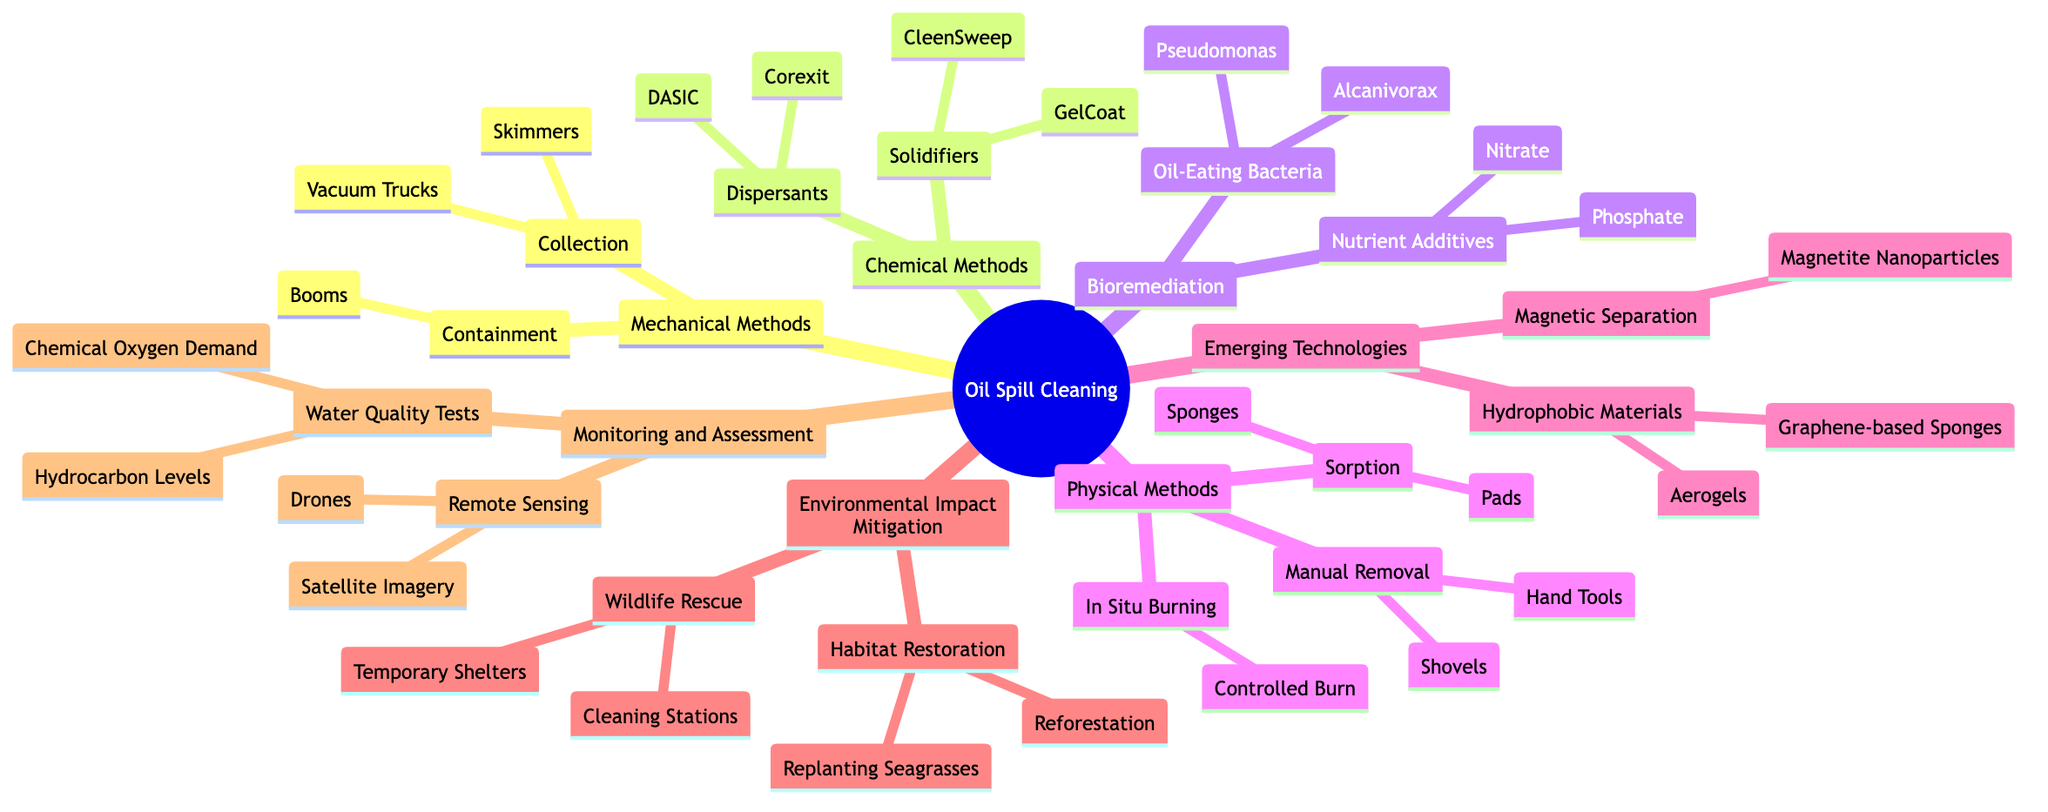What are two types of mechanical methods? The diagram presents "Mechanical Methods" which has two categories: "Containment" and "Collection." These categories represent the ways in which mechanical methods can be classified.
Answer: Containment, Collection How many chemical methods are listed? The "Chemical Methods" section includes two categories: "Dispersants" and "Solidifiers." Each of these categories contains two items, but the question only concerns the number of methods.
Answer: 2 Name a dispersant used in oil spill clean-up. Under the "Chemical Methods" section, specifically in the "Dispersants" category, two examples are provided: "Corexit" and "DASIC." Any of these examples would fulfill the requirement.
Answer: Corexit What is the first item under bioremediation? The "Bioremediation" section lists "Oil-Eating Bacteria" first, which has two specific examples under it. Thus, the answer refers to the first item mentioned in this category.
Answer: Oil-Eating Bacteria How do nutrient additives relate to bioremediation? The "Bioremediation" section includes two subcategories: "Oil-Eating Bacteria" and "Nutrient Additives." Nutrient Additives directly support the bioremediation process by enhancing the effectiveness of the oil-eating bacteria. Therefore, they are connected as supportive elements in cleaning oil spills.
Answer: They support oil-eating bacteria How many items are listed under physical methods? The "Physical Methods" branch has three main categories: "Sorption," "In Situ Burning," and "Manual Removal." Each category contains at least one listed item. To determine the total number of items, we add them up: "Sorption" has two items, "In Situ Burning" has one item, and "Manual Removal" has two items.
Answer: 5 Which emerging technology uses magnetic separation? Under the "Emerging Technologies" section, the category of "Magnetic Separation" specifically includes "Magnetite Nanoparticles." This identifies it as a technology that utilizes magnetic properties to assist in cleaning oil spills.
Answer: Magnetite Nanoparticles What are the two parts of environmental impact mitigation? The "Environmental Impact Mitigation" section consists of two primary categories: "Wildlife Rescue" and "Habitat Restoration." Each category represents a focus area within the broader theme of mitigating effects from oil spills.
Answer: Wildlife Rescue, Habitat Restoration Which monitoring method utilizes drones? The "Monitoring and Assessment" category lists "Remote Sensing," which includes "Drones" as one method. This identifies the specific method that involves the use of aerial technology for monitoring oil spills.
Answer: Remote Sensing 